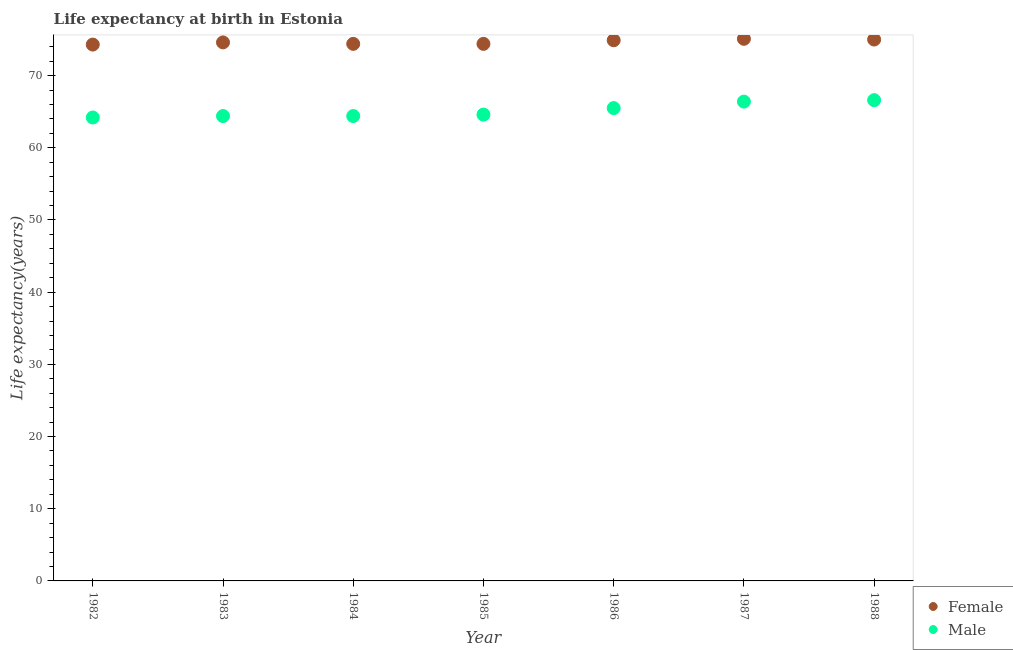How many different coloured dotlines are there?
Your answer should be compact. 2. What is the life expectancy(female) in 1984?
Give a very brief answer. 74.4. Across all years, what is the maximum life expectancy(male)?
Give a very brief answer. 66.6. Across all years, what is the minimum life expectancy(male)?
Your response must be concise. 64.2. What is the total life expectancy(female) in the graph?
Offer a terse response. 522.7. What is the difference between the life expectancy(male) in 1983 and that in 1988?
Offer a terse response. -2.2. What is the difference between the life expectancy(male) in 1982 and the life expectancy(female) in 1986?
Make the answer very short. -10.7. What is the average life expectancy(female) per year?
Your response must be concise. 74.67. In the year 1982, what is the difference between the life expectancy(male) and life expectancy(female)?
Your answer should be very brief. -10.1. What is the ratio of the life expectancy(male) in 1985 to that in 1986?
Offer a terse response. 0.99. Is the difference between the life expectancy(male) in 1982 and 1987 greater than the difference between the life expectancy(female) in 1982 and 1987?
Provide a succinct answer. No. What is the difference between the highest and the second highest life expectancy(female)?
Make the answer very short. 0.1. What is the difference between the highest and the lowest life expectancy(female)?
Make the answer very short. 0.8. In how many years, is the life expectancy(male) greater than the average life expectancy(male) taken over all years?
Your answer should be compact. 3. Is the sum of the life expectancy(male) in 1987 and 1988 greater than the maximum life expectancy(female) across all years?
Provide a succinct answer. Yes. Does the life expectancy(male) monotonically increase over the years?
Your answer should be compact. No. Is the life expectancy(female) strictly greater than the life expectancy(male) over the years?
Offer a very short reply. Yes. How many dotlines are there?
Ensure brevity in your answer.  2. What is the difference between two consecutive major ticks on the Y-axis?
Your answer should be compact. 10. Does the graph contain any zero values?
Your answer should be compact. No. Does the graph contain grids?
Provide a short and direct response. No. Where does the legend appear in the graph?
Your response must be concise. Bottom right. How many legend labels are there?
Your response must be concise. 2. How are the legend labels stacked?
Make the answer very short. Vertical. What is the title of the graph?
Your response must be concise. Life expectancy at birth in Estonia. Does "Current US$" appear as one of the legend labels in the graph?
Offer a very short reply. No. What is the label or title of the X-axis?
Your answer should be very brief. Year. What is the label or title of the Y-axis?
Your response must be concise. Life expectancy(years). What is the Life expectancy(years) in Female in 1982?
Your response must be concise. 74.3. What is the Life expectancy(years) in Male in 1982?
Ensure brevity in your answer.  64.2. What is the Life expectancy(years) in Female in 1983?
Ensure brevity in your answer.  74.6. What is the Life expectancy(years) in Male in 1983?
Make the answer very short. 64.4. What is the Life expectancy(years) of Female in 1984?
Keep it short and to the point. 74.4. What is the Life expectancy(years) in Male in 1984?
Your answer should be compact. 64.4. What is the Life expectancy(years) of Female in 1985?
Your answer should be very brief. 74.4. What is the Life expectancy(years) in Male in 1985?
Offer a very short reply. 64.6. What is the Life expectancy(years) in Female in 1986?
Your answer should be very brief. 74.9. What is the Life expectancy(years) of Male in 1986?
Offer a very short reply. 65.5. What is the Life expectancy(years) of Female in 1987?
Give a very brief answer. 75.1. What is the Life expectancy(years) of Male in 1987?
Your answer should be compact. 66.4. What is the Life expectancy(years) in Male in 1988?
Your answer should be very brief. 66.6. Across all years, what is the maximum Life expectancy(years) of Female?
Your answer should be compact. 75.1. Across all years, what is the maximum Life expectancy(years) of Male?
Keep it short and to the point. 66.6. Across all years, what is the minimum Life expectancy(years) in Female?
Give a very brief answer. 74.3. Across all years, what is the minimum Life expectancy(years) of Male?
Make the answer very short. 64.2. What is the total Life expectancy(years) in Female in the graph?
Offer a terse response. 522.7. What is the total Life expectancy(years) in Male in the graph?
Your response must be concise. 456.1. What is the difference between the Life expectancy(years) of Female in 1982 and that in 1983?
Give a very brief answer. -0.3. What is the difference between the Life expectancy(years) of Male in 1982 and that in 1984?
Your answer should be compact. -0.2. What is the difference between the Life expectancy(years) in Male in 1982 and that in 1985?
Keep it short and to the point. -0.4. What is the difference between the Life expectancy(years) of Female in 1982 and that in 1986?
Your answer should be very brief. -0.6. What is the difference between the Life expectancy(years) of Male in 1982 and that in 1986?
Provide a short and direct response. -1.3. What is the difference between the Life expectancy(years) of Male in 1982 and that in 1987?
Give a very brief answer. -2.2. What is the difference between the Life expectancy(years) of Female in 1983 and that in 1984?
Keep it short and to the point. 0.2. What is the difference between the Life expectancy(years) of Male in 1983 and that in 1985?
Your answer should be very brief. -0.2. What is the difference between the Life expectancy(years) of Male in 1983 and that in 1986?
Provide a short and direct response. -1.1. What is the difference between the Life expectancy(years) in Female in 1983 and that in 1987?
Keep it short and to the point. -0.5. What is the difference between the Life expectancy(years) in Male in 1983 and that in 1988?
Give a very brief answer. -2.2. What is the difference between the Life expectancy(years) in Female in 1984 and that in 1986?
Provide a succinct answer. -0.5. What is the difference between the Life expectancy(years) in Female in 1984 and that in 1988?
Give a very brief answer. -0.6. What is the difference between the Life expectancy(years) of Female in 1985 and that in 1986?
Give a very brief answer. -0.5. What is the difference between the Life expectancy(years) of Male in 1985 and that in 1986?
Your response must be concise. -0.9. What is the difference between the Life expectancy(years) in Female in 1985 and that in 1987?
Offer a very short reply. -0.7. What is the difference between the Life expectancy(years) in Male in 1985 and that in 1987?
Ensure brevity in your answer.  -1.8. What is the difference between the Life expectancy(years) of Female in 1985 and that in 1988?
Provide a short and direct response. -0.6. What is the difference between the Life expectancy(years) in Male in 1985 and that in 1988?
Offer a very short reply. -2. What is the difference between the Life expectancy(years) in Female in 1986 and that in 1988?
Offer a very short reply. -0.1. What is the difference between the Life expectancy(years) in Male in 1986 and that in 1988?
Your answer should be compact. -1.1. What is the difference between the Life expectancy(years) of Male in 1987 and that in 1988?
Your answer should be compact. -0.2. What is the difference between the Life expectancy(years) of Female in 1982 and the Life expectancy(years) of Male in 1983?
Keep it short and to the point. 9.9. What is the difference between the Life expectancy(years) of Female in 1982 and the Life expectancy(years) of Male in 1984?
Provide a short and direct response. 9.9. What is the difference between the Life expectancy(years) in Female in 1982 and the Life expectancy(years) in Male in 1987?
Make the answer very short. 7.9. What is the difference between the Life expectancy(years) in Female in 1982 and the Life expectancy(years) in Male in 1988?
Provide a succinct answer. 7.7. What is the difference between the Life expectancy(years) in Female in 1983 and the Life expectancy(years) in Male in 1984?
Make the answer very short. 10.2. What is the difference between the Life expectancy(years) in Female in 1984 and the Life expectancy(years) in Male in 1987?
Provide a short and direct response. 8. What is the difference between the Life expectancy(years) in Female in 1986 and the Life expectancy(years) in Male in 1987?
Offer a terse response. 8.5. What is the average Life expectancy(years) in Female per year?
Provide a short and direct response. 74.67. What is the average Life expectancy(years) in Male per year?
Ensure brevity in your answer.  65.16. In the year 1982, what is the difference between the Life expectancy(years) of Female and Life expectancy(years) of Male?
Keep it short and to the point. 10.1. In the year 1986, what is the difference between the Life expectancy(years) in Female and Life expectancy(years) in Male?
Your answer should be compact. 9.4. In the year 1987, what is the difference between the Life expectancy(years) in Female and Life expectancy(years) in Male?
Keep it short and to the point. 8.7. In the year 1988, what is the difference between the Life expectancy(years) in Female and Life expectancy(years) in Male?
Offer a very short reply. 8.4. What is the ratio of the Life expectancy(years) of Female in 1982 to that in 1984?
Give a very brief answer. 1. What is the ratio of the Life expectancy(years) of Male in 1982 to that in 1986?
Keep it short and to the point. 0.98. What is the ratio of the Life expectancy(years) in Female in 1982 to that in 1987?
Provide a short and direct response. 0.99. What is the ratio of the Life expectancy(years) of Male in 1982 to that in 1987?
Your answer should be very brief. 0.97. What is the ratio of the Life expectancy(years) of Male in 1982 to that in 1988?
Provide a short and direct response. 0.96. What is the ratio of the Life expectancy(years) in Female in 1983 to that in 1984?
Ensure brevity in your answer.  1. What is the ratio of the Life expectancy(years) in Male in 1983 to that in 1986?
Offer a very short reply. 0.98. What is the ratio of the Life expectancy(years) of Male in 1983 to that in 1987?
Make the answer very short. 0.97. What is the ratio of the Life expectancy(years) of Male in 1984 to that in 1985?
Ensure brevity in your answer.  1. What is the ratio of the Life expectancy(years) of Male in 1984 to that in 1986?
Keep it short and to the point. 0.98. What is the ratio of the Life expectancy(years) of Female in 1984 to that in 1987?
Keep it short and to the point. 0.99. What is the ratio of the Life expectancy(years) in Male in 1984 to that in 1987?
Offer a very short reply. 0.97. What is the ratio of the Life expectancy(years) of Female in 1984 to that in 1988?
Your answer should be compact. 0.99. What is the ratio of the Life expectancy(years) in Female in 1985 to that in 1986?
Offer a terse response. 0.99. What is the ratio of the Life expectancy(years) of Male in 1985 to that in 1986?
Your answer should be very brief. 0.99. What is the ratio of the Life expectancy(years) of Female in 1985 to that in 1987?
Provide a succinct answer. 0.99. What is the ratio of the Life expectancy(years) of Male in 1985 to that in 1987?
Make the answer very short. 0.97. What is the ratio of the Life expectancy(years) in Female in 1985 to that in 1988?
Give a very brief answer. 0.99. What is the ratio of the Life expectancy(years) of Male in 1985 to that in 1988?
Offer a very short reply. 0.97. What is the ratio of the Life expectancy(years) in Female in 1986 to that in 1987?
Provide a short and direct response. 1. What is the ratio of the Life expectancy(years) of Male in 1986 to that in 1987?
Provide a short and direct response. 0.99. What is the ratio of the Life expectancy(years) in Male in 1986 to that in 1988?
Your response must be concise. 0.98. What is the ratio of the Life expectancy(years) of Female in 1987 to that in 1988?
Offer a terse response. 1. What is the ratio of the Life expectancy(years) of Male in 1987 to that in 1988?
Your answer should be very brief. 1. What is the difference between the highest and the lowest Life expectancy(years) of Female?
Provide a succinct answer. 0.8. 